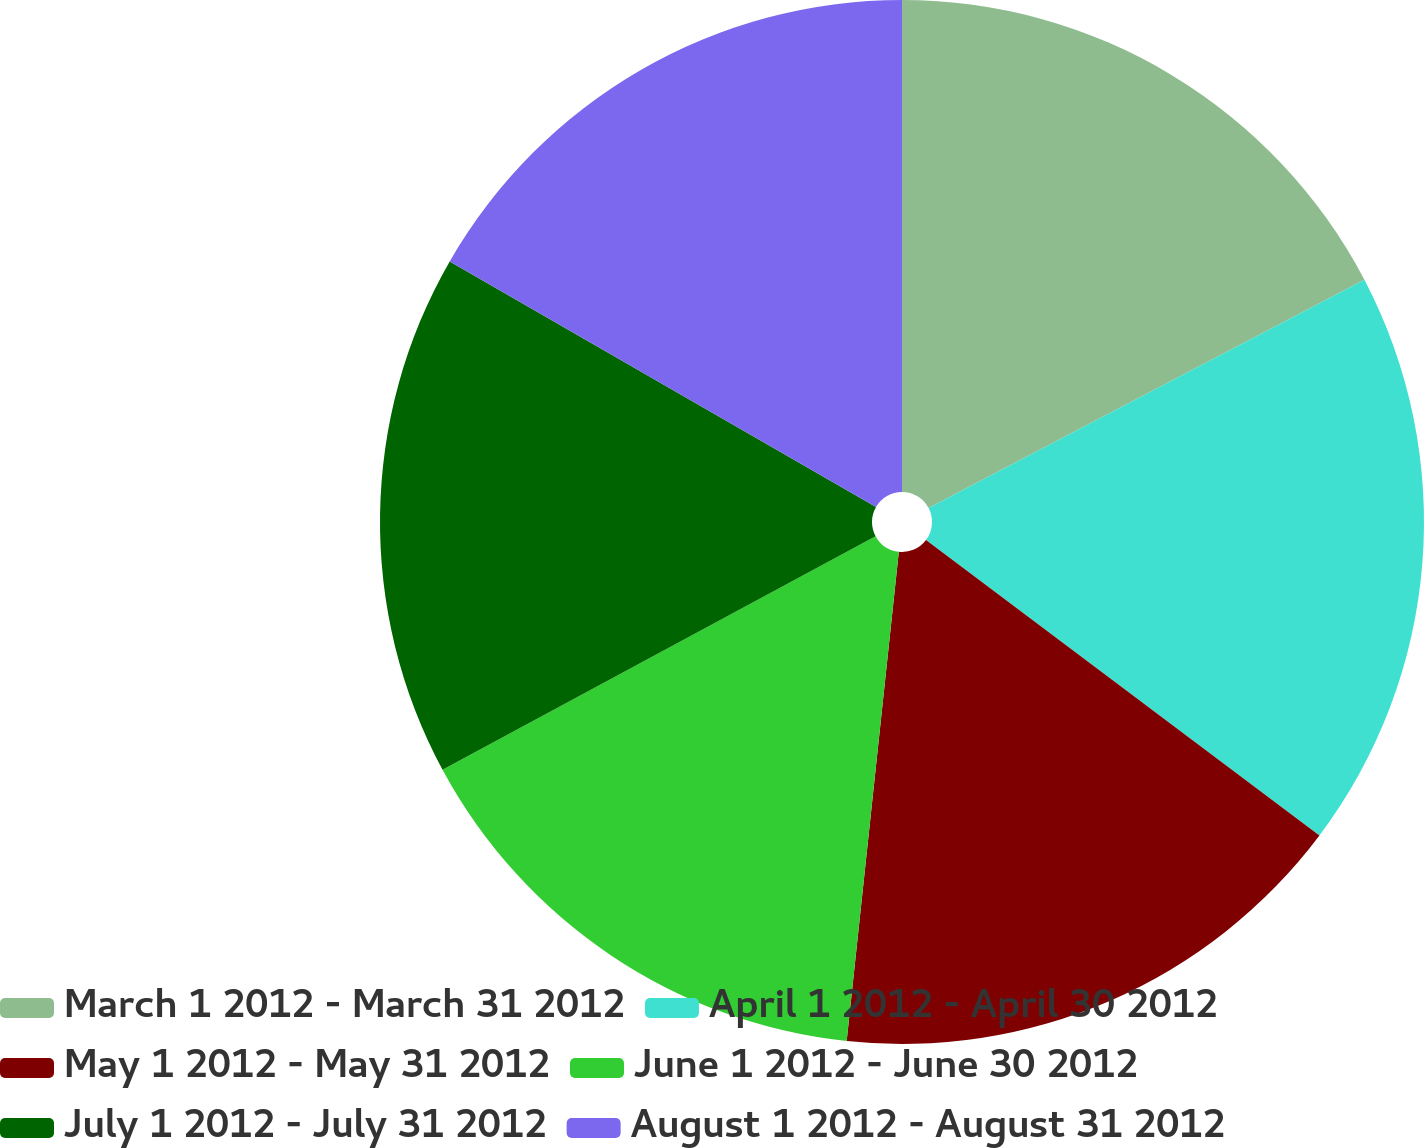Convert chart to OTSL. <chart><loc_0><loc_0><loc_500><loc_500><pie_chart><fcel>March 1 2012 - March 31 2012<fcel>April 1 2012 - April 30 2012<fcel>May 1 2012 - May 31 2012<fcel>June 1 2012 - June 30 2012<fcel>July 1 2012 - July 31 2012<fcel>August 1 2012 - August 31 2012<nl><fcel>17.32%<fcel>17.93%<fcel>16.44%<fcel>15.44%<fcel>16.19%<fcel>16.68%<nl></chart> 